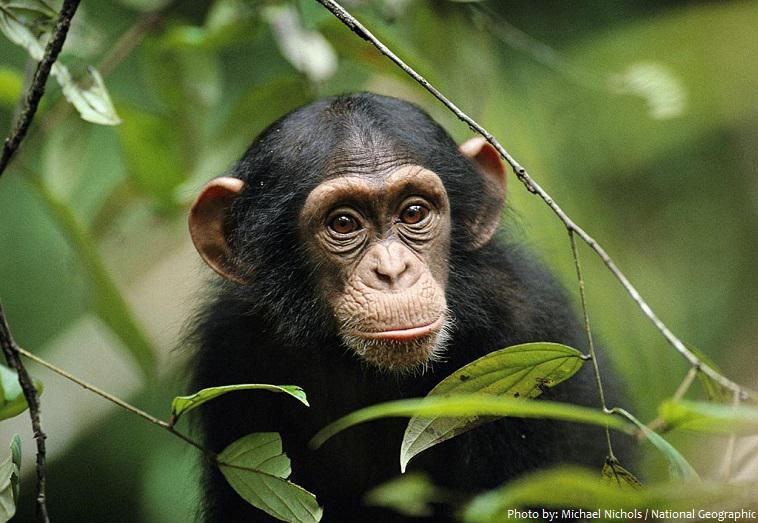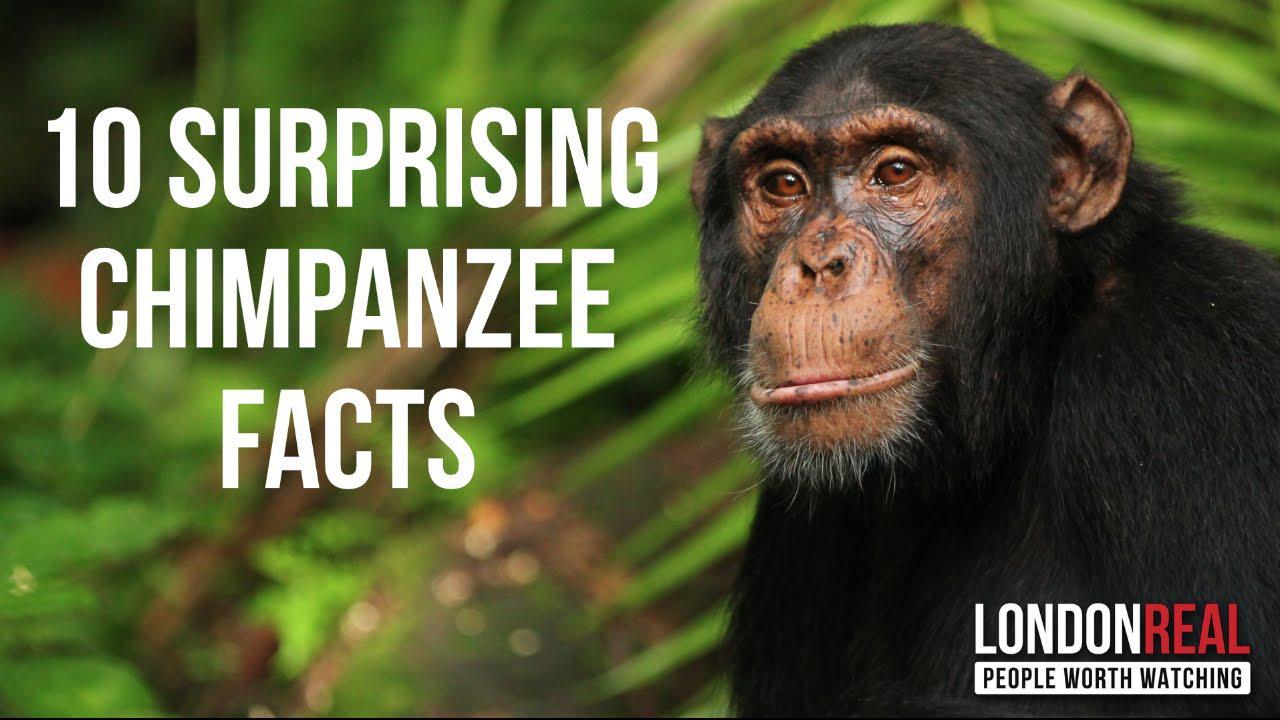The first image is the image on the left, the second image is the image on the right. Considering the images on both sides, is "The right image contains exactly one chimpanzee." valid? Answer yes or no. Yes. The first image is the image on the left, the second image is the image on the right. Given the left and right images, does the statement "There is a single chimp outdoors in each of the images." hold true? Answer yes or no. Yes. 